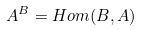<formula> <loc_0><loc_0><loc_500><loc_500>A ^ { B } = H o m ( B , A )</formula> 